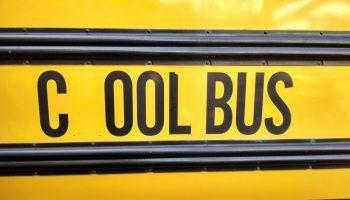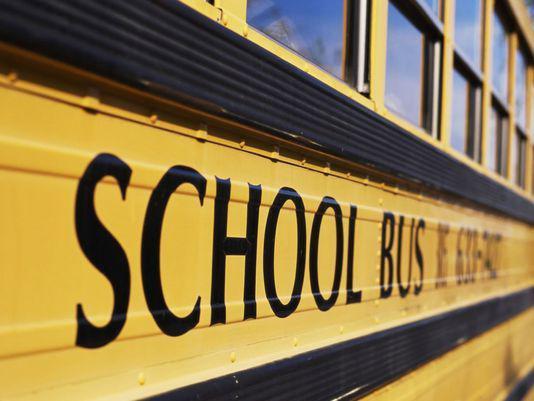The first image is the image on the left, the second image is the image on the right. Evaluate the accuracy of this statement regarding the images: "Words are written across the side of a school bus in the image on the right.". Is it true? Answer yes or no. Yes. The first image is the image on the left, the second image is the image on the right. Given the left and right images, does the statement "The right image contains an aerial view of a school bus parking lot." hold true? Answer yes or no. No. 